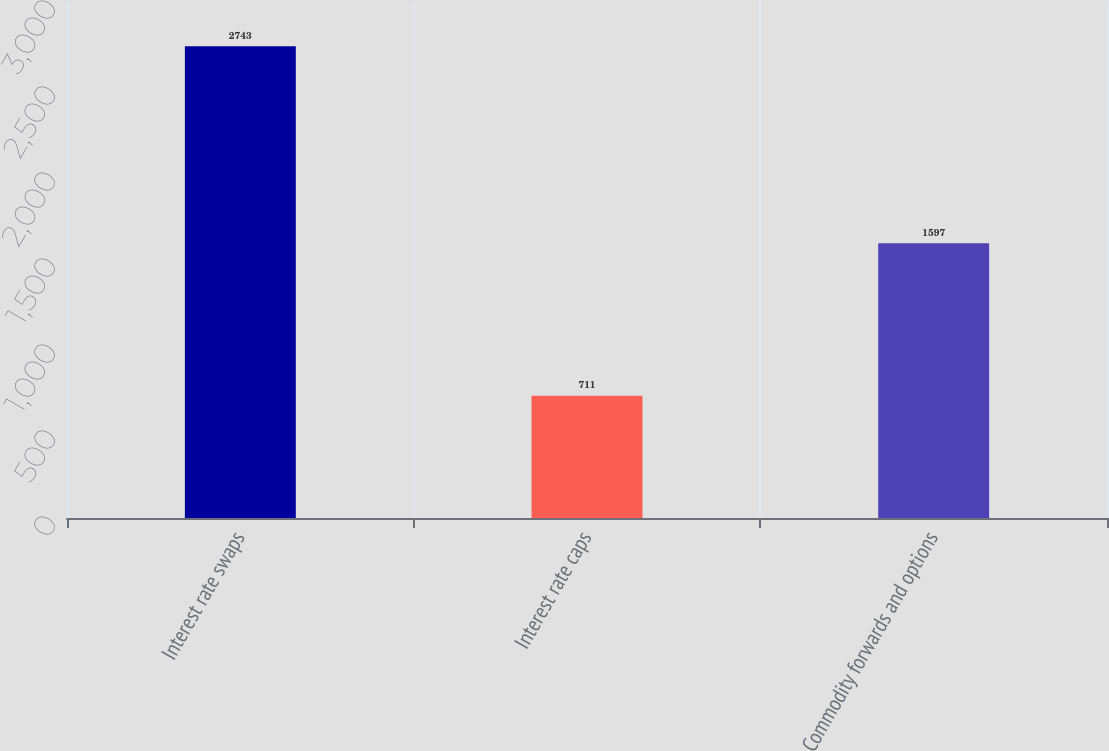Convert chart. <chart><loc_0><loc_0><loc_500><loc_500><bar_chart><fcel>Interest rate swaps<fcel>Interest rate caps<fcel>Commodity forwards and options<nl><fcel>2743<fcel>711<fcel>1597<nl></chart> 